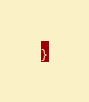<code> <loc_0><loc_0><loc_500><loc_500><_CSS_>}
</code> 